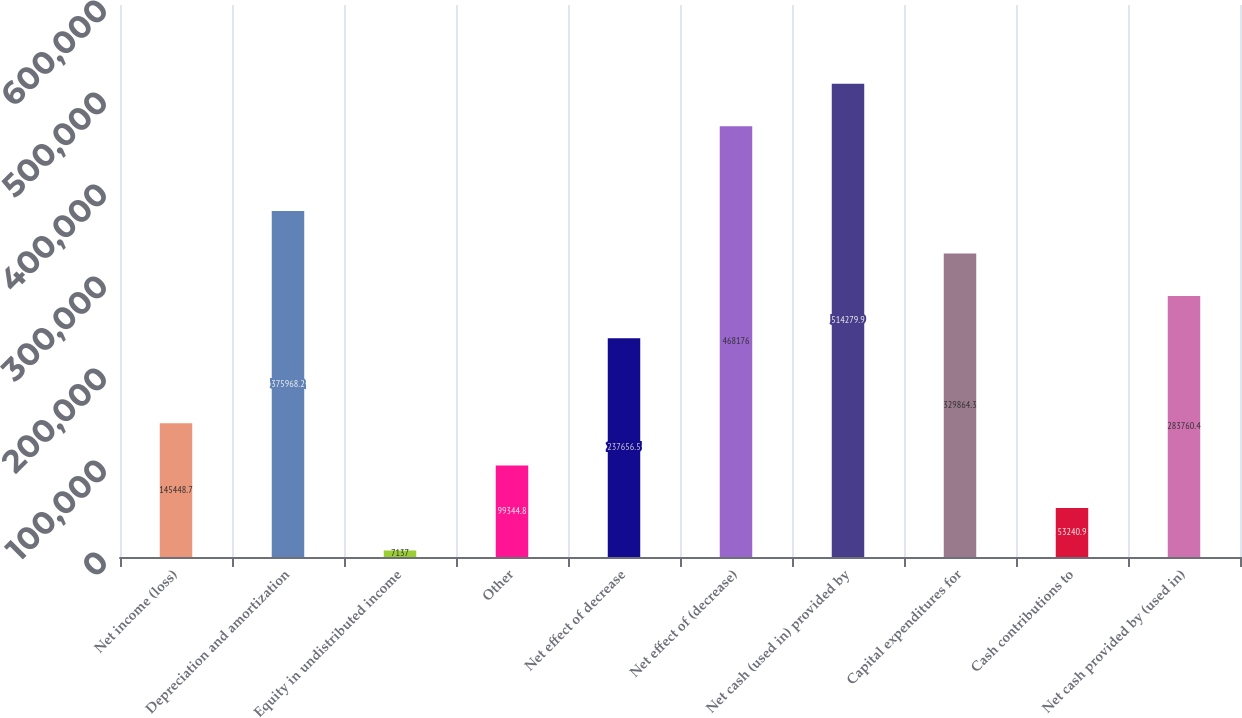Convert chart to OTSL. <chart><loc_0><loc_0><loc_500><loc_500><bar_chart><fcel>Net income (loss)<fcel>Depreciation and amortization<fcel>Equity in undistributed income<fcel>Other<fcel>Net effect of decrease<fcel>Net effect of (decrease)<fcel>Net cash (used in) provided by<fcel>Capital expenditures for<fcel>Cash contributions to<fcel>Net cash provided by (used in)<nl><fcel>145449<fcel>375968<fcel>7137<fcel>99344.8<fcel>237656<fcel>468176<fcel>514280<fcel>329864<fcel>53240.9<fcel>283760<nl></chart> 